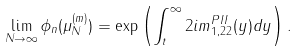<formula> <loc_0><loc_0><loc_500><loc_500>\lim _ { N \to \infty } \phi _ { n } ( \mu _ { N } ^ { ( m ) } ) = \exp \left ( \int _ { t } ^ { \infty } 2 i m ^ { P I I } _ { 1 , 2 2 } ( y ) d y \right ) .</formula> 